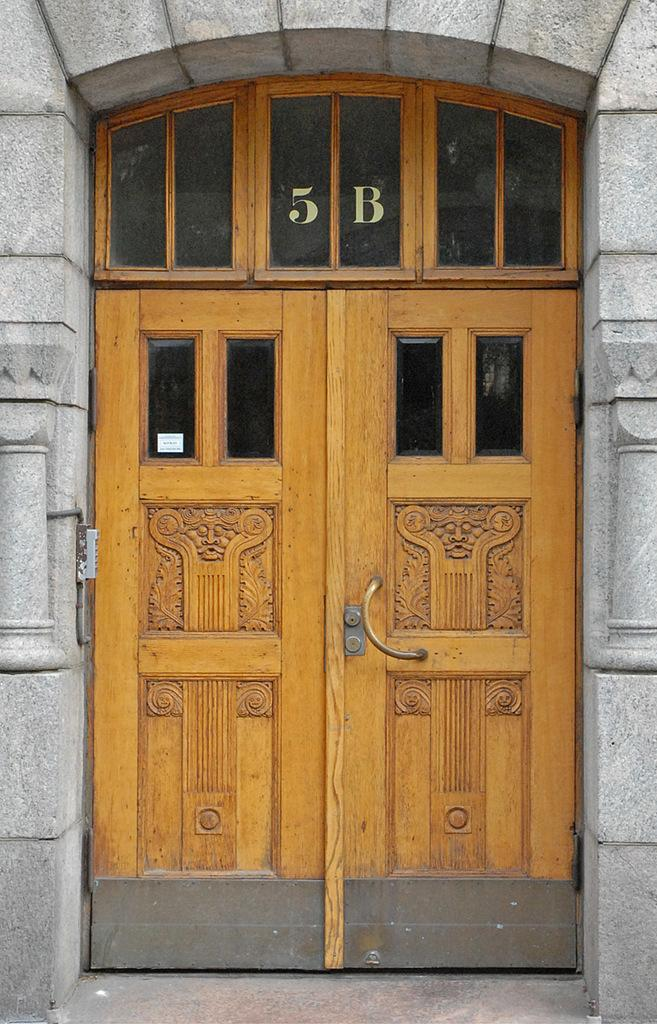What is the main object in the image? There is a door in the image. What type of structure does the door belong to? The door belongs to a house. Is there any specific information written on the door? Yes, the number "5 B" is written on the door. What type of sail can be seen on the door in the image? There is no sail present on the door in the image. How does the brain interact with the door in the image? There is no brain present in the image, so it cannot interact with the door. 